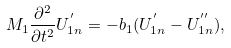Convert formula to latex. <formula><loc_0><loc_0><loc_500><loc_500>M _ { 1 } \frac { \partial ^ { 2 } } { \partial t ^ { 2 } } U _ { 1 n } ^ { ^ { \prime } } = - b _ { 1 } ( U _ { 1 n } ^ { ^ { \prime } } - U _ { 1 n } ^ { ^ { \prime \prime } } ) ,</formula> 